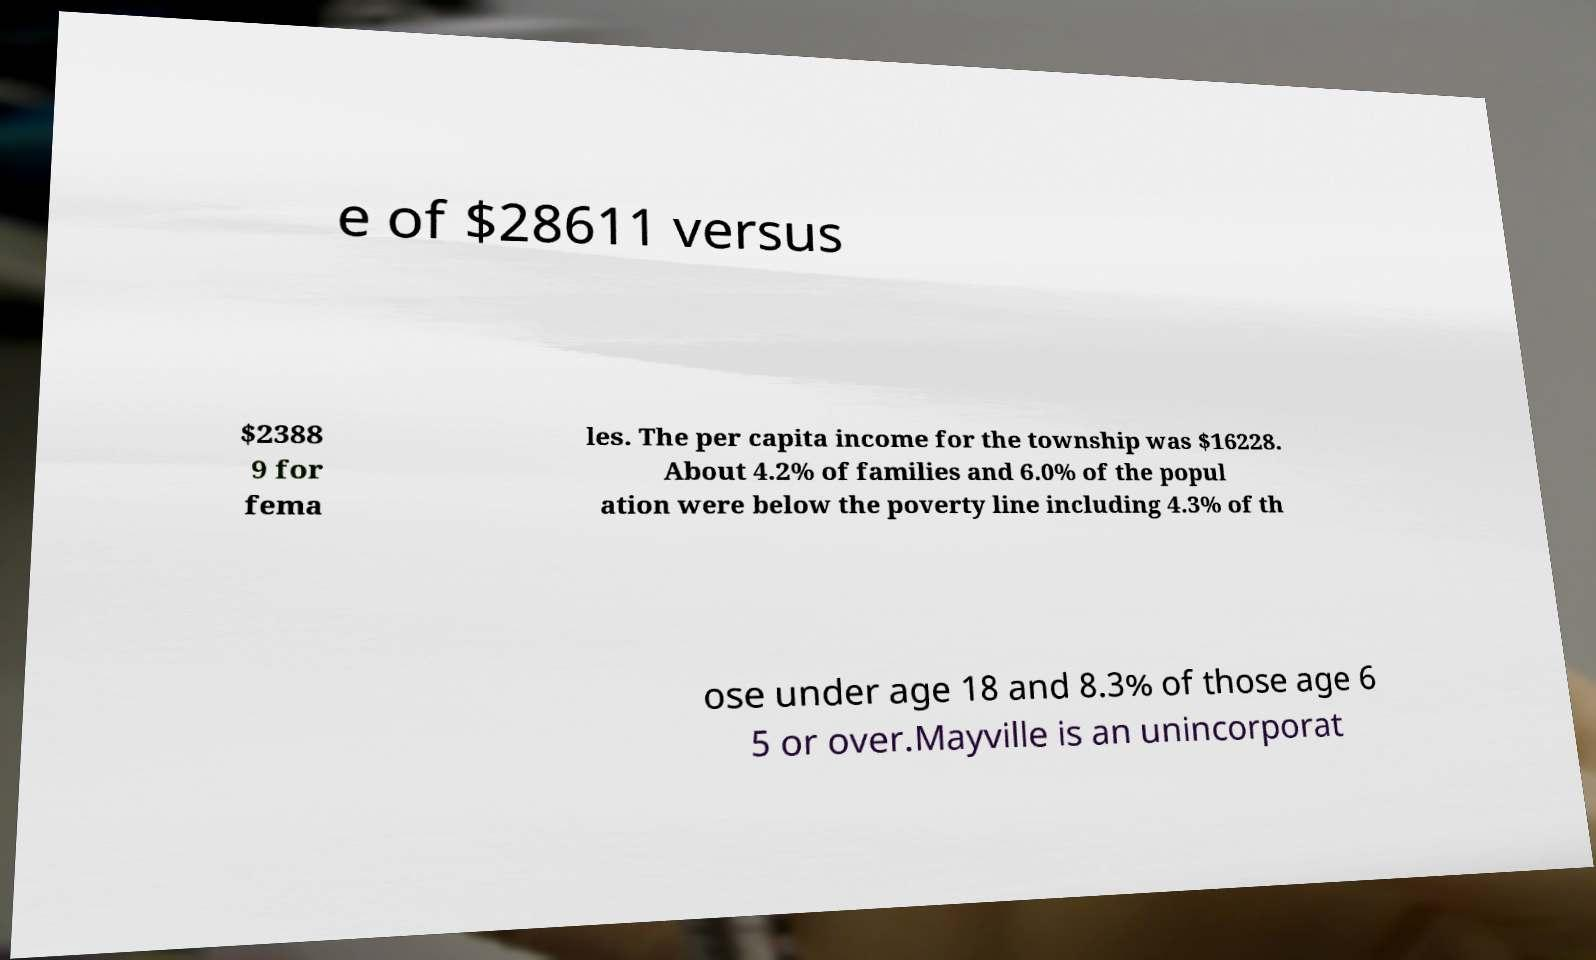For documentation purposes, I need the text within this image transcribed. Could you provide that? e of $28611 versus $2388 9 for fema les. The per capita income for the township was $16228. About 4.2% of families and 6.0% of the popul ation were below the poverty line including 4.3% of th ose under age 18 and 8.3% of those age 6 5 or over.Mayville is an unincorporat 